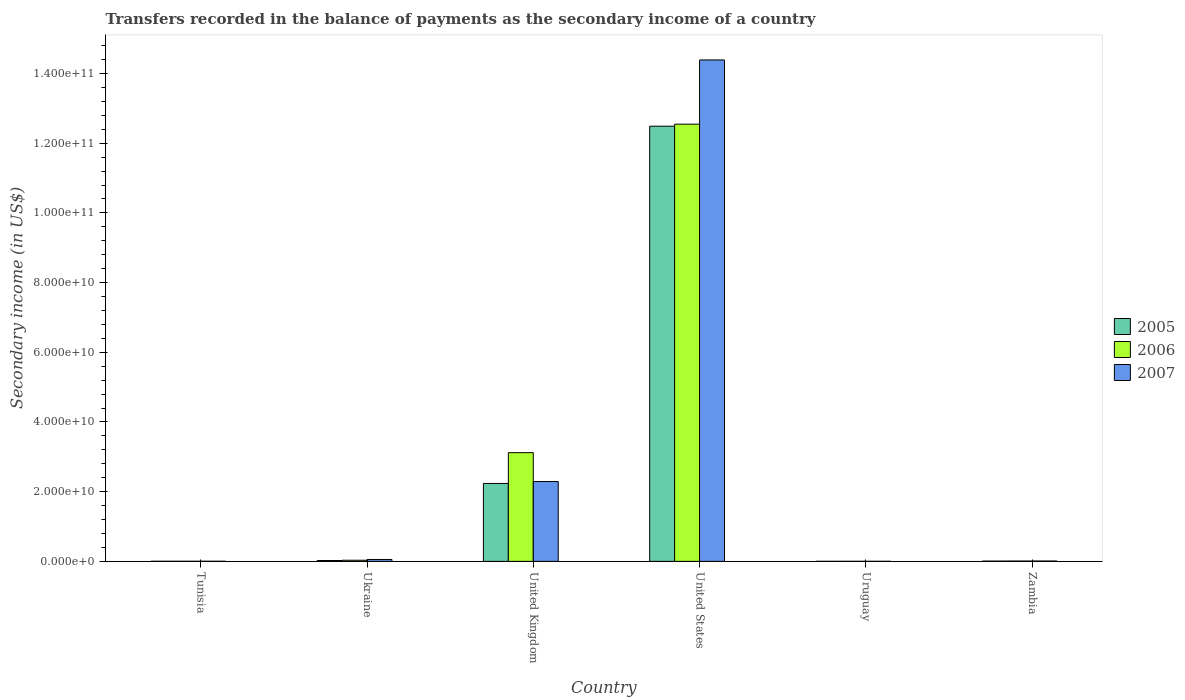How many different coloured bars are there?
Provide a short and direct response. 3. Are the number of bars per tick equal to the number of legend labels?
Keep it short and to the point. Yes. Are the number of bars on each tick of the X-axis equal?
Provide a short and direct response. Yes. What is the secondary income of in 2005 in United Kingdom?
Ensure brevity in your answer.  2.24e+1. Across all countries, what is the maximum secondary income of in 2006?
Provide a succinct answer. 1.25e+11. Across all countries, what is the minimum secondary income of in 2006?
Make the answer very short. 1.10e+07. In which country was the secondary income of in 2005 maximum?
Give a very brief answer. United States. In which country was the secondary income of in 2006 minimum?
Your answer should be very brief. Uruguay. What is the total secondary income of in 2006 in the graph?
Your answer should be very brief. 1.57e+11. What is the difference between the secondary income of in 2006 in Ukraine and that in United States?
Your answer should be compact. -1.25e+11. What is the difference between the secondary income of in 2005 in United Kingdom and the secondary income of in 2006 in Tunisia?
Your answer should be compact. 2.23e+1. What is the average secondary income of in 2006 per country?
Offer a very short reply. 2.62e+1. What is the difference between the secondary income of of/in 2006 and secondary income of of/in 2007 in United Kingdom?
Provide a short and direct response. 8.29e+09. In how many countries, is the secondary income of in 2007 greater than 104000000000 US$?
Your response must be concise. 1. What is the ratio of the secondary income of in 2006 in Tunisia to that in United States?
Provide a succinct answer. 0. Is the secondary income of in 2005 in Tunisia less than that in Ukraine?
Give a very brief answer. Yes. What is the difference between the highest and the second highest secondary income of in 2007?
Keep it short and to the point. 1.43e+11. What is the difference between the highest and the lowest secondary income of in 2005?
Give a very brief answer. 1.25e+11. Is the sum of the secondary income of in 2007 in United Kingdom and Zambia greater than the maximum secondary income of in 2006 across all countries?
Your answer should be very brief. No. How many bars are there?
Provide a succinct answer. 18. Are all the bars in the graph horizontal?
Your answer should be very brief. No. How many countries are there in the graph?
Ensure brevity in your answer.  6. What is the difference between two consecutive major ticks on the Y-axis?
Ensure brevity in your answer.  2.00e+1. What is the title of the graph?
Provide a short and direct response. Transfers recorded in the balance of payments as the secondary income of a country. Does "1992" appear as one of the legend labels in the graph?
Make the answer very short. No. What is the label or title of the Y-axis?
Offer a very short reply. Secondary income (in US$). What is the Secondary income (in US$) in 2005 in Tunisia?
Give a very brief answer. 2.77e+07. What is the Secondary income (in US$) in 2006 in Tunisia?
Your answer should be very brief. 2.70e+07. What is the Secondary income (in US$) of 2007 in Tunisia?
Give a very brief answer. 3.15e+07. What is the Secondary income (in US$) of 2005 in Ukraine?
Ensure brevity in your answer.  2.39e+08. What is the Secondary income (in US$) in 2006 in Ukraine?
Offer a terse response. 3.24e+08. What is the Secondary income (in US$) of 2007 in Ukraine?
Offer a terse response. 5.42e+08. What is the Secondary income (in US$) in 2005 in United Kingdom?
Keep it short and to the point. 2.24e+1. What is the Secondary income (in US$) of 2006 in United Kingdom?
Your answer should be very brief. 3.12e+1. What is the Secondary income (in US$) of 2007 in United Kingdom?
Provide a short and direct response. 2.29e+1. What is the Secondary income (in US$) in 2005 in United States?
Provide a succinct answer. 1.25e+11. What is the Secondary income (in US$) in 2006 in United States?
Your response must be concise. 1.25e+11. What is the Secondary income (in US$) in 2007 in United States?
Offer a very short reply. 1.44e+11. What is the Secondary income (in US$) of 2005 in Uruguay?
Provide a short and direct response. 6.11e+06. What is the Secondary income (in US$) in 2006 in Uruguay?
Your answer should be very brief. 1.10e+07. What is the Secondary income (in US$) in 2007 in Uruguay?
Offer a terse response. 1.37e+07. What is the Secondary income (in US$) in 2005 in Zambia?
Keep it short and to the point. 7.70e+07. What is the Secondary income (in US$) in 2006 in Zambia?
Offer a very short reply. 9.27e+07. What is the Secondary income (in US$) of 2007 in Zambia?
Offer a very short reply. 9.59e+07. Across all countries, what is the maximum Secondary income (in US$) of 2005?
Your answer should be very brief. 1.25e+11. Across all countries, what is the maximum Secondary income (in US$) of 2006?
Provide a short and direct response. 1.25e+11. Across all countries, what is the maximum Secondary income (in US$) in 2007?
Your answer should be very brief. 1.44e+11. Across all countries, what is the minimum Secondary income (in US$) in 2005?
Provide a short and direct response. 6.11e+06. Across all countries, what is the minimum Secondary income (in US$) of 2006?
Offer a very short reply. 1.10e+07. Across all countries, what is the minimum Secondary income (in US$) of 2007?
Give a very brief answer. 1.37e+07. What is the total Secondary income (in US$) of 2005 in the graph?
Provide a short and direct response. 1.48e+11. What is the total Secondary income (in US$) of 2006 in the graph?
Ensure brevity in your answer.  1.57e+11. What is the total Secondary income (in US$) in 2007 in the graph?
Your answer should be very brief. 1.67e+11. What is the difference between the Secondary income (in US$) of 2005 in Tunisia and that in Ukraine?
Your answer should be very brief. -2.11e+08. What is the difference between the Secondary income (in US$) of 2006 in Tunisia and that in Ukraine?
Keep it short and to the point. -2.97e+08. What is the difference between the Secondary income (in US$) in 2007 in Tunisia and that in Ukraine?
Provide a succinct answer. -5.10e+08. What is the difference between the Secondary income (in US$) in 2005 in Tunisia and that in United Kingdom?
Offer a terse response. -2.23e+1. What is the difference between the Secondary income (in US$) of 2006 in Tunisia and that in United Kingdom?
Your answer should be compact. -3.12e+1. What is the difference between the Secondary income (in US$) of 2007 in Tunisia and that in United Kingdom?
Offer a terse response. -2.29e+1. What is the difference between the Secondary income (in US$) of 2005 in Tunisia and that in United States?
Provide a succinct answer. -1.25e+11. What is the difference between the Secondary income (in US$) of 2006 in Tunisia and that in United States?
Provide a short and direct response. -1.25e+11. What is the difference between the Secondary income (in US$) in 2007 in Tunisia and that in United States?
Your answer should be compact. -1.44e+11. What is the difference between the Secondary income (in US$) of 2005 in Tunisia and that in Uruguay?
Ensure brevity in your answer.  2.16e+07. What is the difference between the Secondary income (in US$) of 2006 in Tunisia and that in Uruguay?
Provide a succinct answer. 1.60e+07. What is the difference between the Secondary income (in US$) of 2007 in Tunisia and that in Uruguay?
Provide a short and direct response. 1.78e+07. What is the difference between the Secondary income (in US$) of 2005 in Tunisia and that in Zambia?
Provide a succinct answer. -4.93e+07. What is the difference between the Secondary income (in US$) of 2006 in Tunisia and that in Zambia?
Make the answer very short. -6.57e+07. What is the difference between the Secondary income (in US$) in 2007 in Tunisia and that in Zambia?
Keep it short and to the point. -6.44e+07. What is the difference between the Secondary income (in US$) of 2005 in Ukraine and that in United Kingdom?
Make the answer very short. -2.21e+1. What is the difference between the Secondary income (in US$) of 2006 in Ukraine and that in United Kingdom?
Your response must be concise. -3.09e+1. What is the difference between the Secondary income (in US$) of 2007 in Ukraine and that in United Kingdom?
Your answer should be very brief. -2.24e+1. What is the difference between the Secondary income (in US$) in 2005 in Ukraine and that in United States?
Your answer should be very brief. -1.25e+11. What is the difference between the Secondary income (in US$) of 2006 in Ukraine and that in United States?
Ensure brevity in your answer.  -1.25e+11. What is the difference between the Secondary income (in US$) in 2007 in Ukraine and that in United States?
Provide a succinct answer. -1.43e+11. What is the difference between the Secondary income (in US$) in 2005 in Ukraine and that in Uruguay?
Keep it short and to the point. 2.33e+08. What is the difference between the Secondary income (in US$) in 2006 in Ukraine and that in Uruguay?
Ensure brevity in your answer.  3.13e+08. What is the difference between the Secondary income (in US$) in 2007 in Ukraine and that in Uruguay?
Provide a succinct answer. 5.28e+08. What is the difference between the Secondary income (in US$) of 2005 in Ukraine and that in Zambia?
Offer a terse response. 1.62e+08. What is the difference between the Secondary income (in US$) of 2006 in Ukraine and that in Zambia?
Offer a terse response. 2.31e+08. What is the difference between the Secondary income (in US$) in 2007 in Ukraine and that in Zambia?
Keep it short and to the point. 4.46e+08. What is the difference between the Secondary income (in US$) of 2005 in United Kingdom and that in United States?
Keep it short and to the point. -1.03e+11. What is the difference between the Secondary income (in US$) of 2006 in United Kingdom and that in United States?
Ensure brevity in your answer.  -9.43e+1. What is the difference between the Secondary income (in US$) in 2007 in United Kingdom and that in United States?
Your response must be concise. -1.21e+11. What is the difference between the Secondary income (in US$) of 2005 in United Kingdom and that in Uruguay?
Offer a terse response. 2.24e+1. What is the difference between the Secondary income (in US$) in 2006 in United Kingdom and that in Uruguay?
Provide a short and direct response. 3.12e+1. What is the difference between the Secondary income (in US$) of 2007 in United Kingdom and that in Uruguay?
Make the answer very short. 2.29e+1. What is the difference between the Secondary income (in US$) in 2005 in United Kingdom and that in Zambia?
Your answer should be compact. 2.23e+1. What is the difference between the Secondary income (in US$) in 2006 in United Kingdom and that in Zambia?
Make the answer very short. 3.11e+1. What is the difference between the Secondary income (in US$) in 2007 in United Kingdom and that in Zambia?
Provide a succinct answer. 2.28e+1. What is the difference between the Secondary income (in US$) in 2005 in United States and that in Uruguay?
Offer a very short reply. 1.25e+11. What is the difference between the Secondary income (in US$) in 2006 in United States and that in Uruguay?
Provide a short and direct response. 1.25e+11. What is the difference between the Secondary income (in US$) in 2007 in United States and that in Uruguay?
Ensure brevity in your answer.  1.44e+11. What is the difference between the Secondary income (in US$) of 2005 in United States and that in Zambia?
Keep it short and to the point. 1.25e+11. What is the difference between the Secondary income (in US$) in 2006 in United States and that in Zambia?
Ensure brevity in your answer.  1.25e+11. What is the difference between the Secondary income (in US$) of 2007 in United States and that in Zambia?
Your response must be concise. 1.44e+11. What is the difference between the Secondary income (in US$) of 2005 in Uruguay and that in Zambia?
Make the answer very short. -7.09e+07. What is the difference between the Secondary income (in US$) in 2006 in Uruguay and that in Zambia?
Your answer should be compact. -8.17e+07. What is the difference between the Secondary income (in US$) in 2007 in Uruguay and that in Zambia?
Provide a succinct answer. -8.22e+07. What is the difference between the Secondary income (in US$) of 2005 in Tunisia and the Secondary income (in US$) of 2006 in Ukraine?
Ensure brevity in your answer.  -2.96e+08. What is the difference between the Secondary income (in US$) in 2005 in Tunisia and the Secondary income (in US$) in 2007 in Ukraine?
Your answer should be very brief. -5.14e+08. What is the difference between the Secondary income (in US$) in 2006 in Tunisia and the Secondary income (in US$) in 2007 in Ukraine?
Give a very brief answer. -5.15e+08. What is the difference between the Secondary income (in US$) in 2005 in Tunisia and the Secondary income (in US$) in 2006 in United Kingdom?
Make the answer very short. -3.12e+1. What is the difference between the Secondary income (in US$) in 2005 in Tunisia and the Secondary income (in US$) in 2007 in United Kingdom?
Offer a terse response. -2.29e+1. What is the difference between the Secondary income (in US$) of 2006 in Tunisia and the Secondary income (in US$) of 2007 in United Kingdom?
Ensure brevity in your answer.  -2.29e+1. What is the difference between the Secondary income (in US$) in 2005 in Tunisia and the Secondary income (in US$) in 2006 in United States?
Give a very brief answer. -1.25e+11. What is the difference between the Secondary income (in US$) of 2005 in Tunisia and the Secondary income (in US$) of 2007 in United States?
Provide a succinct answer. -1.44e+11. What is the difference between the Secondary income (in US$) in 2006 in Tunisia and the Secondary income (in US$) in 2007 in United States?
Make the answer very short. -1.44e+11. What is the difference between the Secondary income (in US$) in 2005 in Tunisia and the Secondary income (in US$) in 2006 in Uruguay?
Your response must be concise. 1.66e+07. What is the difference between the Secondary income (in US$) of 2005 in Tunisia and the Secondary income (in US$) of 2007 in Uruguay?
Your response must be concise. 1.40e+07. What is the difference between the Secondary income (in US$) in 2006 in Tunisia and the Secondary income (in US$) in 2007 in Uruguay?
Your answer should be compact. 1.33e+07. What is the difference between the Secondary income (in US$) in 2005 in Tunisia and the Secondary income (in US$) in 2006 in Zambia?
Keep it short and to the point. -6.51e+07. What is the difference between the Secondary income (in US$) of 2005 in Tunisia and the Secondary income (in US$) of 2007 in Zambia?
Your answer should be compact. -6.82e+07. What is the difference between the Secondary income (in US$) of 2006 in Tunisia and the Secondary income (in US$) of 2007 in Zambia?
Your response must be concise. -6.89e+07. What is the difference between the Secondary income (in US$) of 2005 in Ukraine and the Secondary income (in US$) of 2006 in United Kingdom?
Provide a short and direct response. -3.10e+1. What is the difference between the Secondary income (in US$) of 2005 in Ukraine and the Secondary income (in US$) of 2007 in United Kingdom?
Give a very brief answer. -2.27e+1. What is the difference between the Secondary income (in US$) of 2006 in Ukraine and the Secondary income (in US$) of 2007 in United Kingdom?
Provide a succinct answer. -2.26e+1. What is the difference between the Secondary income (in US$) in 2005 in Ukraine and the Secondary income (in US$) in 2006 in United States?
Your answer should be compact. -1.25e+11. What is the difference between the Secondary income (in US$) in 2005 in Ukraine and the Secondary income (in US$) in 2007 in United States?
Your answer should be compact. -1.44e+11. What is the difference between the Secondary income (in US$) of 2006 in Ukraine and the Secondary income (in US$) of 2007 in United States?
Your answer should be very brief. -1.44e+11. What is the difference between the Secondary income (in US$) of 2005 in Ukraine and the Secondary income (in US$) of 2006 in Uruguay?
Your answer should be compact. 2.28e+08. What is the difference between the Secondary income (in US$) of 2005 in Ukraine and the Secondary income (in US$) of 2007 in Uruguay?
Provide a succinct answer. 2.25e+08. What is the difference between the Secondary income (in US$) of 2006 in Ukraine and the Secondary income (in US$) of 2007 in Uruguay?
Your answer should be very brief. 3.10e+08. What is the difference between the Secondary income (in US$) of 2005 in Ukraine and the Secondary income (in US$) of 2006 in Zambia?
Offer a very short reply. 1.46e+08. What is the difference between the Secondary income (in US$) of 2005 in Ukraine and the Secondary income (in US$) of 2007 in Zambia?
Ensure brevity in your answer.  1.43e+08. What is the difference between the Secondary income (in US$) of 2006 in Ukraine and the Secondary income (in US$) of 2007 in Zambia?
Your response must be concise. 2.28e+08. What is the difference between the Secondary income (in US$) in 2005 in United Kingdom and the Secondary income (in US$) in 2006 in United States?
Your response must be concise. -1.03e+11. What is the difference between the Secondary income (in US$) in 2005 in United Kingdom and the Secondary income (in US$) in 2007 in United States?
Provide a succinct answer. -1.22e+11. What is the difference between the Secondary income (in US$) in 2006 in United Kingdom and the Secondary income (in US$) in 2007 in United States?
Your answer should be very brief. -1.13e+11. What is the difference between the Secondary income (in US$) in 2005 in United Kingdom and the Secondary income (in US$) in 2006 in Uruguay?
Give a very brief answer. 2.24e+1. What is the difference between the Secondary income (in US$) in 2005 in United Kingdom and the Secondary income (in US$) in 2007 in Uruguay?
Ensure brevity in your answer.  2.23e+1. What is the difference between the Secondary income (in US$) of 2006 in United Kingdom and the Secondary income (in US$) of 2007 in Uruguay?
Provide a short and direct response. 3.12e+1. What is the difference between the Secondary income (in US$) of 2005 in United Kingdom and the Secondary income (in US$) of 2006 in Zambia?
Your answer should be compact. 2.23e+1. What is the difference between the Secondary income (in US$) in 2005 in United Kingdom and the Secondary income (in US$) in 2007 in Zambia?
Give a very brief answer. 2.23e+1. What is the difference between the Secondary income (in US$) of 2006 in United Kingdom and the Secondary income (in US$) of 2007 in Zambia?
Your response must be concise. 3.11e+1. What is the difference between the Secondary income (in US$) in 2005 in United States and the Secondary income (in US$) in 2006 in Uruguay?
Your answer should be compact. 1.25e+11. What is the difference between the Secondary income (in US$) in 2005 in United States and the Secondary income (in US$) in 2007 in Uruguay?
Offer a very short reply. 1.25e+11. What is the difference between the Secondary income (in US$) of 2006 in United States and the Secondary income (in US$) of 2007 in Uruguay?
Provide a succinct answer. 1.25e+11. What is the difference between the Secondary income (in US$) of 2005 in United States and the Secondary income (in US$) of 2006 in Zambia?
Your answer should be compact. 1.25e+11. What is the difference between the Secondary income (in US$) of 2005 in United States and the Secondary income (in US$) of 2007 in Zambia?
Your answer should be very brief. 1.25e+11. What is the difference between the Secondary income (in US$) in 2006 in United States and the Secondary income (in US$) in 2007 in Zambia?
Your answer should be very brief. 1.25e+11. What is the difference between the Secondary income (in US$) of 2005 in Uruguay and the Secondary income (in US$) of 2006 in Zambia?
Provide a short and direct response. -8.66e+07. What is the difference between the Secondary income (in US$) of 2005 in Uruguay and the Secondary income (in US$) of 2007 in Zambia?
Your answer should be very brief. -8.98e+07. What is the difference between the Secondary income (in US$) in 2006 in Uruguay and the Secondary income (in US$) in 2007 in Zambia?
Provide a succinct answer. -8.49e+07. What is the average Secondary income (in US$) in 2005 per country?
Your response must be concise. 2.46e+1. What is the average Secondary income (in US$) of 2006 per country?
Keep it short and to the point. 2.62e+1. What is the average Secondary income (in US$) of 2007 per country?
Provide a short and direct response. 2.79e+1. What is the difference between the Secondary income (in US$) of 2005 and Secondary income (in US$) of 2006 in Tunisia?
Give a very brief answer. 6.23e+05. What is the difference between the Secondary income (in US$) in 2005 and Secondary income (in US$) in 2007 in Tunisia?
Keep it short and to the point. -3.86e+06. What is the difference between the Secondary income (in US$) in 2006 and Secondary income (in US$) in 2007 in Tunisia?
Give a very brief answer. -4.48e+06. What is the difference between the Secondary income (in US$) of 2005 and Secondary income (in US$) of 2006 in Ukraine?
Keep it short and to the point. -8.50e+07. What is the difference between the Secondary income (in US$) of 2005 and Secondary income (in US$) of 2007 in Ukraine?
Provide a succinct answer. -3.03e+08. What is the difference between the Secondary income (in US$) of 2006 and Secondary income (in US$) of 2007 in Ukraine?
Provide a short and direct response. -2.18e+08. What is the difference between the Secondary income (in US$) in 2005 and Secondary income (in US$) in 2006 in United Kingdom?
Your answer should be very brief. -8.84e+09. What is the difference between the Secondary income (in US$) of 2005 and Secondary income (in US$) of 2007 in United Kingdom?
Provide a short and direct response. -5.48e+08. What is the difference between the Secondary income (in US$) in 2006 and Secondary income (in US$) in 2007 in United Kingdom?
Offer a terse response. 8.29e+09. What is the difference between the Secondary income (in US$) of 2005 and Secondary income (in US$) of 2006 in United States?
Ensure brevity in your answer.  -5.83e+08. What is the difference between the Secondary income (in US$) of 2005 and Secondary income (in US$) of 2007 in United States?
Offer a very short reply. -1.90e+1. What is the difference between the Secondary income (in US$) in 2006 and Secondary income (in US$) in 2007 in United States?
Keep it short and to the point. -1.84e+1. What is the difference between the Secondary income (in US$) in 2005 and Secondary income (in US$) in 2006 in Uruguay?
Your answer should be very brief. -4.93e+06. What is the difference between the Secondary income (in US$) of 2005 and Secondary income (in US$) of 2007 in Uruguay?
Offer a very short reply. -7.60e+06. What is the difference between the Secondary income (in US$) in 2006 and Secondary income (in US$) in 2007 in Uruguay?
Keep it short and to the point. -2.67e+06. What is the difference between the Secondary income (in US$) of 2005 and Secondary income (in US$) of 2006 in Zambia?
Provide a succinct answer. -1.58e+07. What is the difference between the Secondary income (in US$) in 2005 and Secondary income (in US$) in 2007 in Zambia?
Your answer should be very brief. -1.89e+07. What is the difference between the Secondary income (in US$) of 2006 and Secondary income (in US$) of 2007 in Zambia?
Provide a succinct answer. -3.16e+06. What is the ratio of the Secondary income (in US$) in 2005 in Tunisia to that in Ukraine?
Provide a short and direct response. 0.12. What is the ratio of the Secondary income (in US$) of 2006 in Tunisia to that in Ukraine?
Offer a terse response. 0.08. What is the ratio of the Secondary income (in US$) in 2007 in Tunisia to that in Ukraine?
Provide a short and direct response. 0.06. What is the ratio of the Secondary income (in US$) of 2005 in Tunisia to that in United Kingdom?
Your answer should be compact. 0. What is the ratio of the Secondary income (in US$) of 2006 in Tunisia to that in United Kingdom?
Your response must be concise. 0. What is the ratio of the Secondary income (in US$) of 2007 in Tunisia to that in United Kingdom?
Make the answer very short. 0. What is the ratio of the Secondary income (in US$) of 2005 in Tunisia to that in Uruguay?
Provide a succinct answer. 4.53. What is the ratio of the Secondary income (in US$) in 2006 in Tunisia to that in Uruguay?
Offer a very short reply. 2.45. What is the ratio of the Secondary income (in US$) of 2007 in Tunisia to that in Uruguay?
Give a very brief answer. 2.3. What is the ratio of the Secondary income (in US$) in 2005 in Tunisia to that in Zambia?
Make the answer very short. 0.36. What is the ratio of the Secondary income (in US$) of 2006 in Tunisia to that in Zambia?
Your response must be concise. 0.29. What is the ratio of the Secondary income (in US$) of 2007 in Tunisia to that in Zambia?
Ensure brevity in your answer.  0.33. What is the ratio of the Secondary income (in US$) of 2005 in Ukraine to that in United Kingdom?
Your response must be concise. 0.01. What is the ratio of the Secondary income (in US$) in 2006 in Ukraine to that in United Kingdom?
Your answer should be compact. 0.01. What is the ratio of the Secondary income (in US$) of 2007 in Ukraine to that in United Kingdom?
Your answer should be compact. 0.02. What is the ratio of the Secondary income (in US$) in 2005 in Ukraine to that in United States?
Ensure brevity in your answer.  0. What is the ratio of the Secondary income (in US$) in 2006 in Ukraine to that in United States?
Your answer should be very brief. 0. What is the ratio of the Secondary income (in US$) in 2007 in Ukraine to that in United States?
Your answer should be very brief. 0. What is the ratio of the Secondary income (in US$) of 2005 in Ukraine to that in Uruguay?
Provide a succinct answer. 39.12. What is the ratio of the Secondary income (in US$) in 2006 in Ukraine to that in Uruguay?
Make the answer very short. 29.34. What is the ratio of the Secondary income (in US$) in 2007 in Ukraine to that in Uruguay?
Make the answer very short. 39.53. What is the ratio of the Secondary income (in US$) of 2005 in Ukraine to that in Zambia?
Make the answer very short. 3.11. What is the ratio of the Secondary income (in US$) in 2006 in Ukraine to that in Zambia?
Provide a short and direct response. 3.49. What is the ratio of the Secondary income (in US$) in 2007 in Ukraine to that in Zambia?
Give a very brief answer. 5.65. What is the ratio of the Secondary income (in US$) in 2005 in United Kingdom to that in United States?
Keep it short and to the point. 0.18. What is the ratio of the Secondary income (in US$) in 2006 in United Kingdom to that in United States?
Keep it short and to the point. 0.25. What is the ratio of the Secondary income (in US$) of 2007 in United Kingdom to that in United States?
Offer a very short reply. 0.16. What is the ratio of the Secondary income (in US$) of 2005 in United Kingdom to that in Uruguay?
Offer a very short reply. 3660.45. What is the ratio of the Secondary income (in US$) in 2006 in United Kingdom to that in Uruguay?
Provide a short and direct response. 2825.35. What is the ratio of the Secondary income (in US$) of 2007 in United Kingdom to that in Uruguay?
Make the answer very short. 1670.79. What is the ratio of the Secondary income (in US$) of 2005 in United Kingdom to that in Zambia?
Keep it short and to the point. 290.55. What is the ratio of the Secondary income (in US$) in 2006 in United Kingdom to that in Zambia?
Ensure brevity in your answer.  336.44. What is the ratio of the Secondary income (in US$) of 2007 in United Kingdom to that in Zambia?
Keep it short and to the point. 238.89. What is the ratio of the Secondary income (in US$) of 2005 in United States to that in Uruguay?
Offer a very short reply. 2.04e+04. What is the ratio of the Secondary income (in US$) in 2006 in United States to that in Uruguay?
Provide a succinct answer. 1.14e+04. What is the ratio of the Secondary income (in US$) of 2007 in United States to that in Uruguay?
Your response must be concise. 1.05e+04. What is the ratio of the Secondary income (in US$) in 2005 in United States to that in Zambia?
Offer a terse response. 1622.64. What is the ratio of the Secondary income (in US$) of 2006 in United States to that in Zambia?
Your answer should be compact. 1352.91. What is the ratio of the Secondary income (in US$) of 2007 in United States to that in Zambia?
Keep it short and to the point. 1500.45. What is the ratio of the Secondary income (in US$) of 2005 in Uruguay to that in Zambia?
Give a very brief answer. 0.08. What is the ratio of the Secondary income (in US$) in 2006 in Uruguay to that in Zambia?
Provide a short and direct response. 0.12. What is the ratio of the Secondary income (in US$) in 2007 in Uruguay to that in Zambia?
Offer a terse response. 0.14. What is the difference between the highest and the second highest Secondary income (in US$) of 2005?
Offer a very short reply. 1.03e+11. What is the difference between the highest and the second highest Secondary income (in US$) of 2006?
Your response must be concise. 9.43e+1. What is the difference between the highest and the second highest Secondary income (in US$) in 2007?
Make the answer very short. 1.21e+11. What is the difference between the highest and the lowest Secondary income (in US$) in 2005?
Offer a terse response. 1.25e+11. What is the difference between the highest and the lowest Secondary income (in US$) in 2006?
Keep it short and to the point. 1.25e+11. What is the difference between the highest and the lowest Secondary income (in US$) of 2007?
Offer a very short reply. 1.44e+11. 